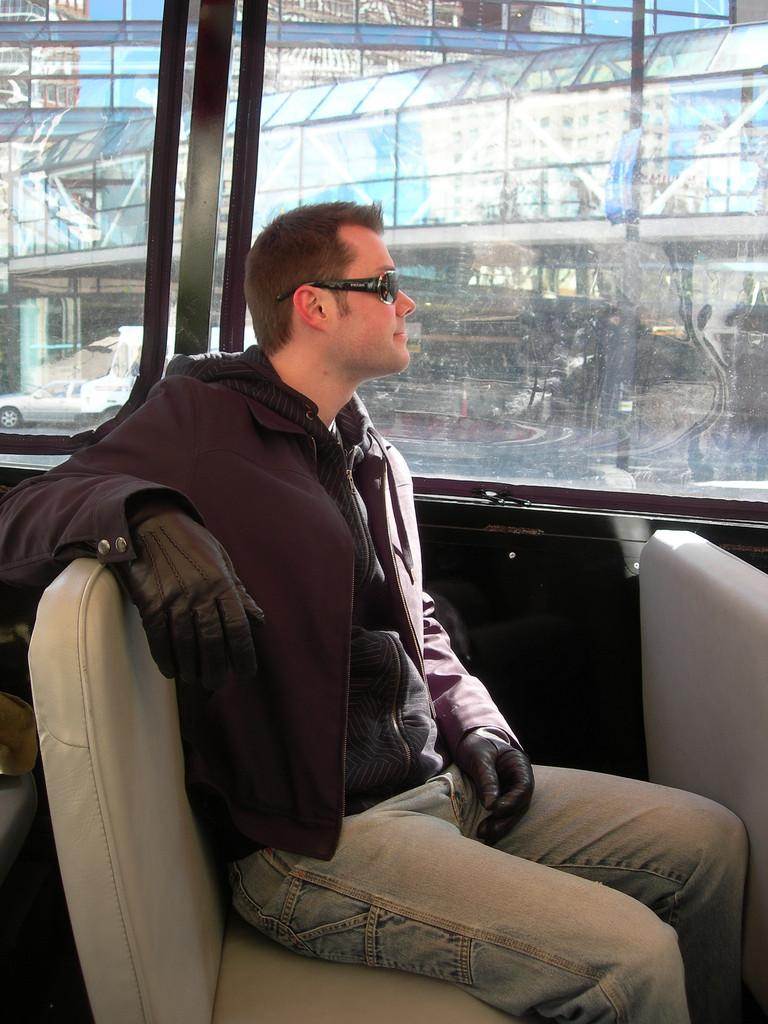What is the main subject of the image? There is a person in the image. What can be observed about the person's attire? The person is wearing clothes. Where is the person located in relation to the window? The person is sitting beside a window. What type of accessories is the person wearing? The person is wearing gloves and sunglasses. What type of animals can be seen at the zoo in the image? There is no zoo present in the image; it features a person sitting beside a window. What type of wool is being used to make the person's gloves in the image? There is no information about the type of wool used for the gloves in the image. --- Facts: 1. There is a car in the image. 2. The car is red. 3. The car has four wheels. 4. The car has a license plate. 5. The car is parked on the street. Absurd Topics: parrot, sand, dance Conversation: What is the main subject of the image? There is a car in the image. What color is the car? The car is red. How many wheels does the car have? The car has four wheels. Does the car have any identifying features? Yes, the car has a license plate. Where is the car located in the image? The car is parked on the street. Reasoning: Let's think step by step in order to produce the conversation. We start by identifying the main subject of the image, which is the car. Then, we describe the car's color, noting that it is red. Next, we observe the car's wheels, noting that it has four. We then mention the car's identifying feature, which is the license plate. Finally, we describe the car's location, which is parked on the street. Absurd Question/Answer: Can you tell me how many parrots are sitting on the car's roof in the image? There are no parrots present in the image; it features a red car parked on the street. What type of dance is being performed by the car in the image? Cars do not perform dances; they are inanimate objects. 